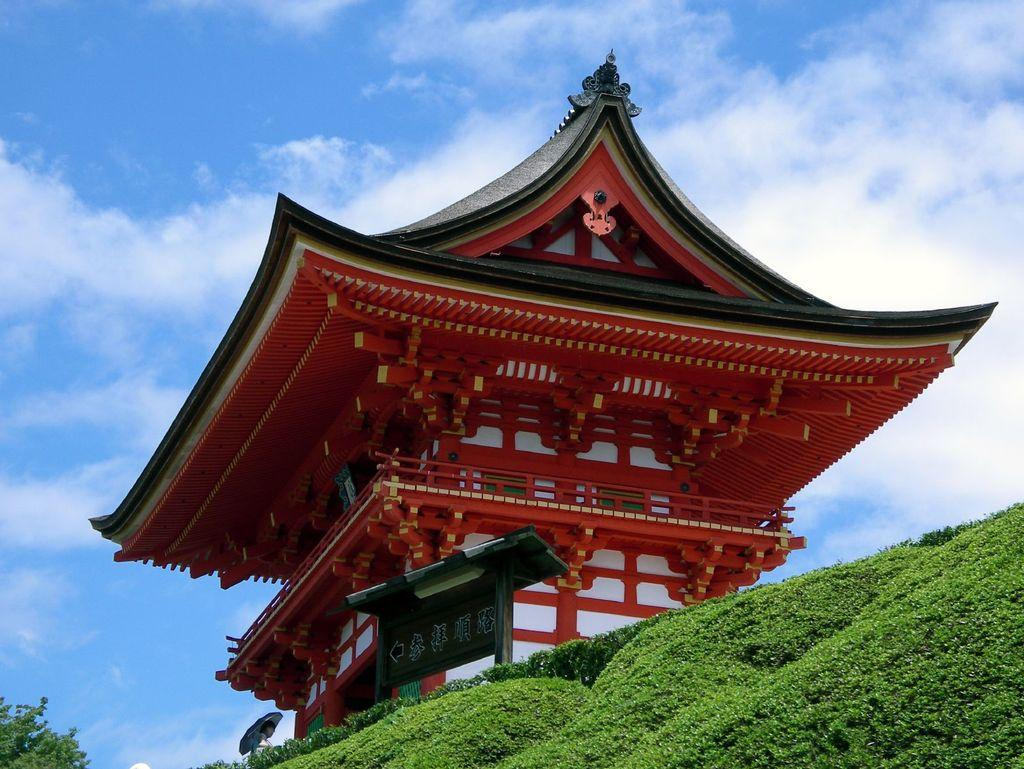What type of structure is depicted in the image? There is a small house in the image that resembles a temple. What can be seen at the bottom of the image? There is green grass at the bottom of the image. What is located on the left side of the image? There is a tree on the left side of the image. What is visible in the sky at the top of the image? There are clouds in the sky at the top of the image. Is there a ball being attacked by the clouds in the image? No, there is no ball or any indication of an attack in the image. The image features a small house, green grass, a tree, and clouds in the sky. 